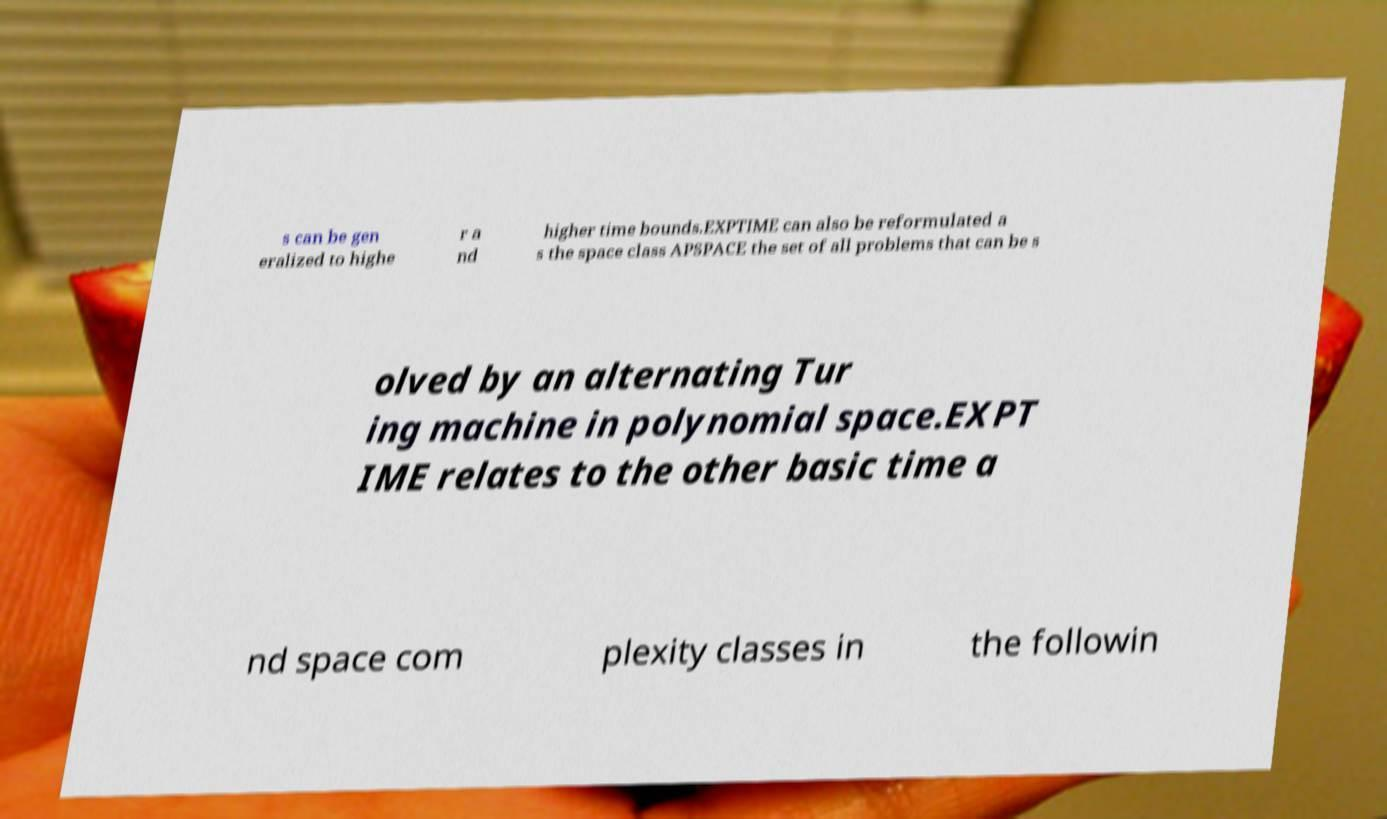Please identify and transcribe the text found in this image. s can be gen eralized to highe r a nd higher time bounds.EXPTIME can also be reformulated a s the space class APSPACE the set of all problems that can be s olved by an alternating Tur ing machine in polynomial space.EXPT IME relates to the other basic time a nd space com plexity classes in the followin 